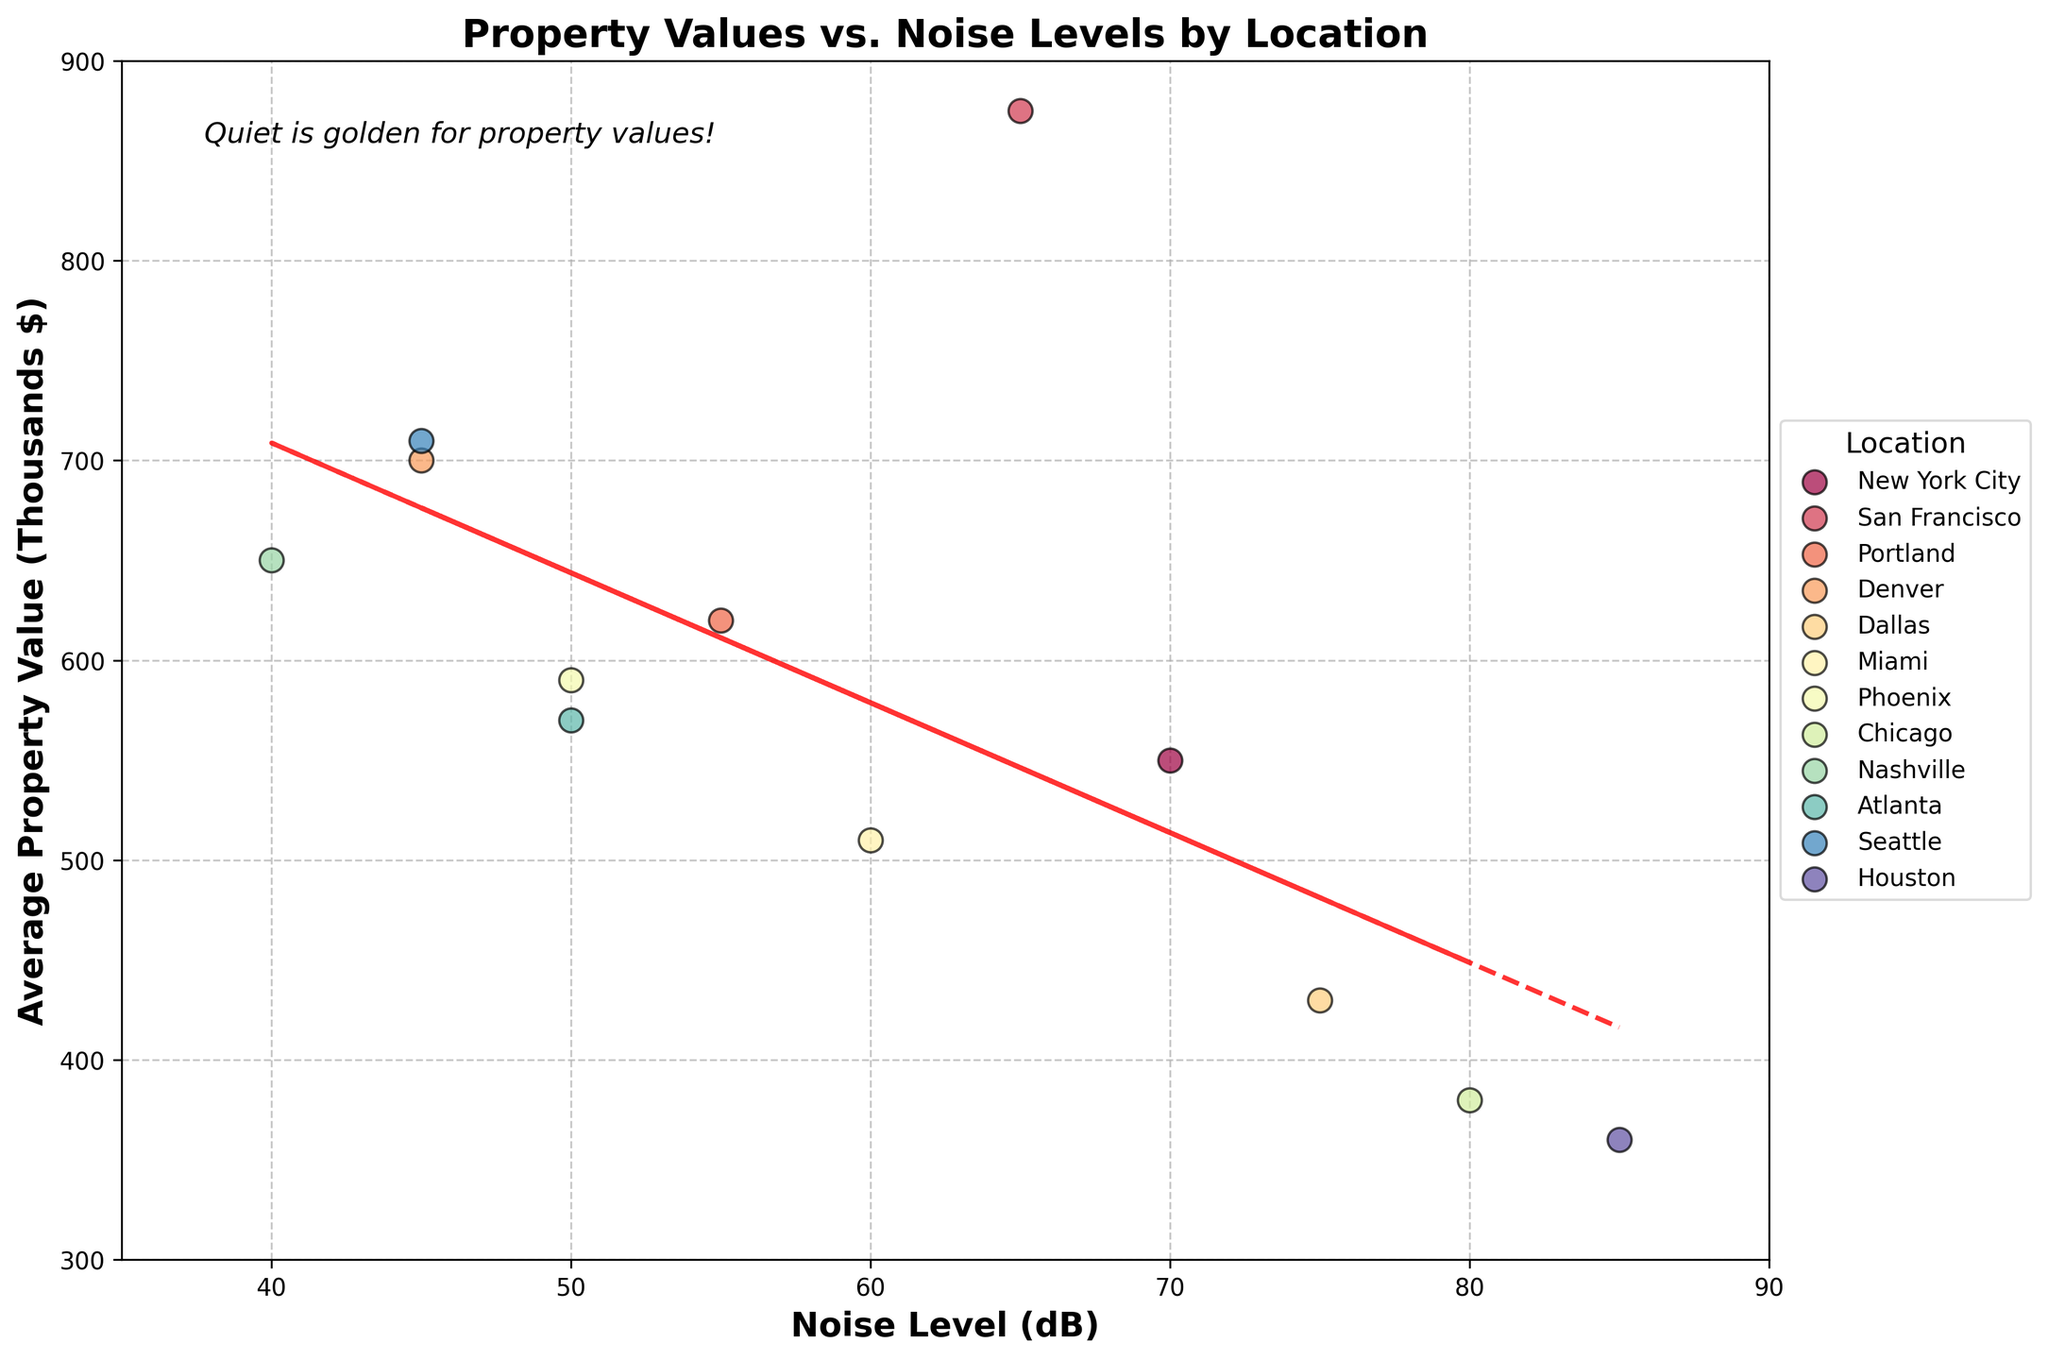What is the title of the plot? The title of the plot is written at the top and summarizes the content of the figure. It is "Property Values vs. Noise Levels by Location".
Answer: Property Values vs. Noise Levels by Location What does the x-axis represent? The label on the x-axis, located at the bottom of the plot, indicates what the axis represents: "Noise Level (dB)".
Answer: Noise Level (dB) Which location has the highest average property value? To determine the location with the highest average property value, look at the y-axis values and identify the highest point. The point for "Sunnyvale Residences, San Francisco" at approximately 875 (thousands $) is the highest.
Answer: Sunnyvale Residences, San Francisco What color represents properties in Miami? Each location is represented by a unique color in the scatter plot, and Miami is specifically labeled with a color corresponding to points on the plot. The color used for Miami points should be identified.
Answer: Light green (or the color visible on the figure) How many properties are shown in the plot? Count the total number of data points representing properties in the scatter plot. Each point corresponds to one property.
Answer: 12 How does the lowest noise level affect property values according to the trend line? Observe the trend line that illustrates the relationship between noise levels and property values. At the lowest noise level (around 40 dB), the trend suggests higher property values around 650 thousand dollars.
Answer: Higher property values Which property has the highest noise level? Identify the property that corresponds to the highest x-axis value for noise levels. This is "Noisy Neighbor Villas, Houston" with 85 dB.
Answer: Noisy Neighbor Villas, Houston How does noise level affect property values overall according to the trend line? The trend line added to the plot shows the general relationship trend. As noise levels increase, you can observe whether property values tend to increase, decrease, or remain constant. The red dashed line indicates that property values decrease with increasing noise levels.
Answer: Property values decrease with higher noise levels Compare the average property values in Denver and Dallas. Look for the property points labeled "Peaceful Hills, Denver" and "Rustic Pines, Dallas". Compare their y-axis values: Denver is at 700 thousand dollars, and Dallas is at 430 thousand dollars.
Answer: Denver: 700k, Dallas: 430k Which property in a location with a 50 dB noise level has a higher value, and by how much? Identify properties at the 50 dB noise level: "Calm Corner, Phoenix" and "Whispering Heights, Atlanta". Compare their y-axis values: Phoenix is at 590 thousand dollars, Atlanta is at 570 thousand dollars. The difference is 20 thousand dollars.
Answer: Calm Corner, Phoenix by 20k 